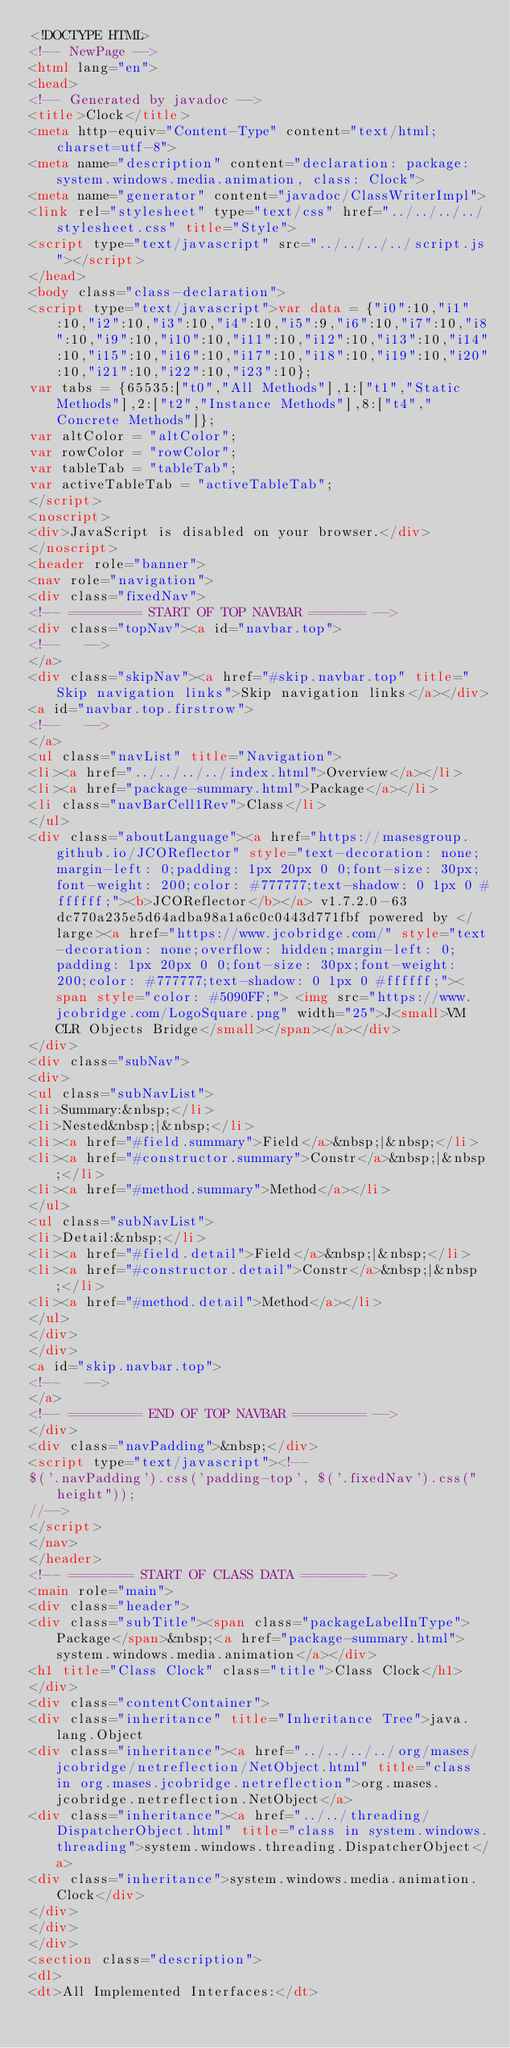Convert code to text. <code><loc_0><loc_0><loc_500><loc_500><_HTML_><!DOCTYPE HTML>
<!-- NewPage -->
<html lang="en">
<head>
<!-- Generated by javadoc -->
<title>Clock</title>
<meta http-equiv="Content-Type" content="text/html; charset=utf-8">
<meta name="description" content="declaration: package: system.windows.media.animation, class: Clock">
<meta name="generator" content="javadoc/ClassWriterImpl">
<link rel="stylesheet" type="text/css" href="../../../../stylesheet.css" title="Style">
<script type="text/javascript" src="../../../../script.js"></script>
</head>
<body class="class-declaration">
<script type="text/javascript">var data = {"i0":10,"i1":10,"i2":10,"i3":10,"i4":10,"i5":9,"i6":10,"i7":10,"i8":10,"i9":10,"i10":10,"i11":10,"i12":10,"i13":10,"i14":10,"i15":10,"i16":10,"i17":10,"i18":10,"i19":10,"i20":10,"i21":10,"i22":10,"i23":10};
var tabs = {65535:["t0","All Methods"],1:["t1","Static Methods"],2:["t2","Instance Methods"],8:["t4","Concrete Methods"]};
var altColor = "altColor";
var rowColor = "rowColor";
var tableTab = "tableTab";
var activeTableTab = "activeTableTab";
</script>
<noscript>
<div>JavaScript is disabled on your browser.</div>
</noscript>
<header role="banner">
<nav role="navigation">
<div class="fixedNav">
<!-- ========= START OF TOP NAVBAR ======= -->
<div class="topNav"><a id="navbar.top">
<!--   -->
</a>
<div class="skipNav"><a href="#skip.navbar.top" title="Skip navigation links">Skip navigation links</a></div>
<a id="navbar.top.firstrow">
<!--   -->
</a>
<ul class="navList" title="Navigation">
<li><a href="../../../../index.html">Overview</a></li>
<li><a href="package-summary.html">Package</a></li>
<li class="navBarCell1Rev">Class</li>
</ul>
<div class="aboutLanguage"><a href="https://masesgroup.github.io/JCOReflector" style="text-decoration: none;margin-left: 0;padding: 1px 20px 0 0;font-size: 30px;font-weight: 200;color: #777777;text-shadow: 0 1px 0 #ffffff;"><b>JCOReflector</b></a> v1.7.2.0-63dc770a235e5d64adba98a1a6c0c0443d771fbf powered by </large><a href="https://www.jcobridge.com/" style="text-decoration: none;overflow: hidden;margin-left: 0;padding: 1px 20px 0 0;font-size: 30px;font-weight: 200;color: #777777;text-shadow: 0 1px 0 #ffffff;"><span style="color: #5090FF;"> <img src="https://www.jcobridge.com/LogoSquare.png" width="25">J<small>VM CLR Objects Bridge</small></span></a></div>
</div>
<div class="subNav">
<div>
<ul class="subNavList">
<li>Summary:&nbsp;</li>
<li>Nested&nbsp;|&nbsp;</li>
<li><a href="#field.summary">Field</a>&nbsp;|&nbsp;</li>
<li><a href="#constructor.summary">Constr</a>&nbsp;|&nbsp;</li>
<li><a href="#method.summary">Method</a></li>
</ul>
<ul class="subNavList">
<li>Detail:&nbsp;</li>
<li><a href="#field.detail">Field</a>&nbsp;|&nbsp;</li>
<li><a href="#constructor.detail">Constr</a>&nbsp;|&nbsp;</li>
<li><a href="#method.detail">Method</a></li>
</ul>
</div>
</div>
<a id="skip.navbar.top">
<!--   -->
</a>
<!-- ========= END OF TOP NAVBAR ========= -->
</div>
<div class="navPadding">&nbsp;</div>
<script type="text/javascript"><!--
$('.navPadding').css('padding-top', $('.fixedNav').css("height"));
//-->
</script>
</nav>
</header>
<!-- ======== START OF CLASS DATA ======== -->
<main role="main">
<div class="header">
<div class="subTitle"><span class="packageLabelInType">Package</span>&nbsp;<a href="package-summary.html">system.windows.media.animation</a></div>
<h1 title="Class Clock" class="title">Class Clock</h1>
</div>
<div class="contentContainer">
<div class="inheritance" title="Inheritance Tree">java.lang.Object
<div class="inheritance"><a href="../../../../org/mases/jcobridge/netreflection/NetObject.html" title="class in org.mases.jcobridge.netreflection">org.mases.jcobridge.netreflection.NetObject</a>
<div class="inheritance"><a href="../../threading/DispatcherObject.html" title="class in system.windows.threading">system.windows.threading.DispatcherObject</a>
<div class="inheritance">system.windows.media.animation.Clock</div>
</div>
</div>
</div>
<section class="description">
<dl>
<dt>All Implemented Interfaces:</dt></code> 